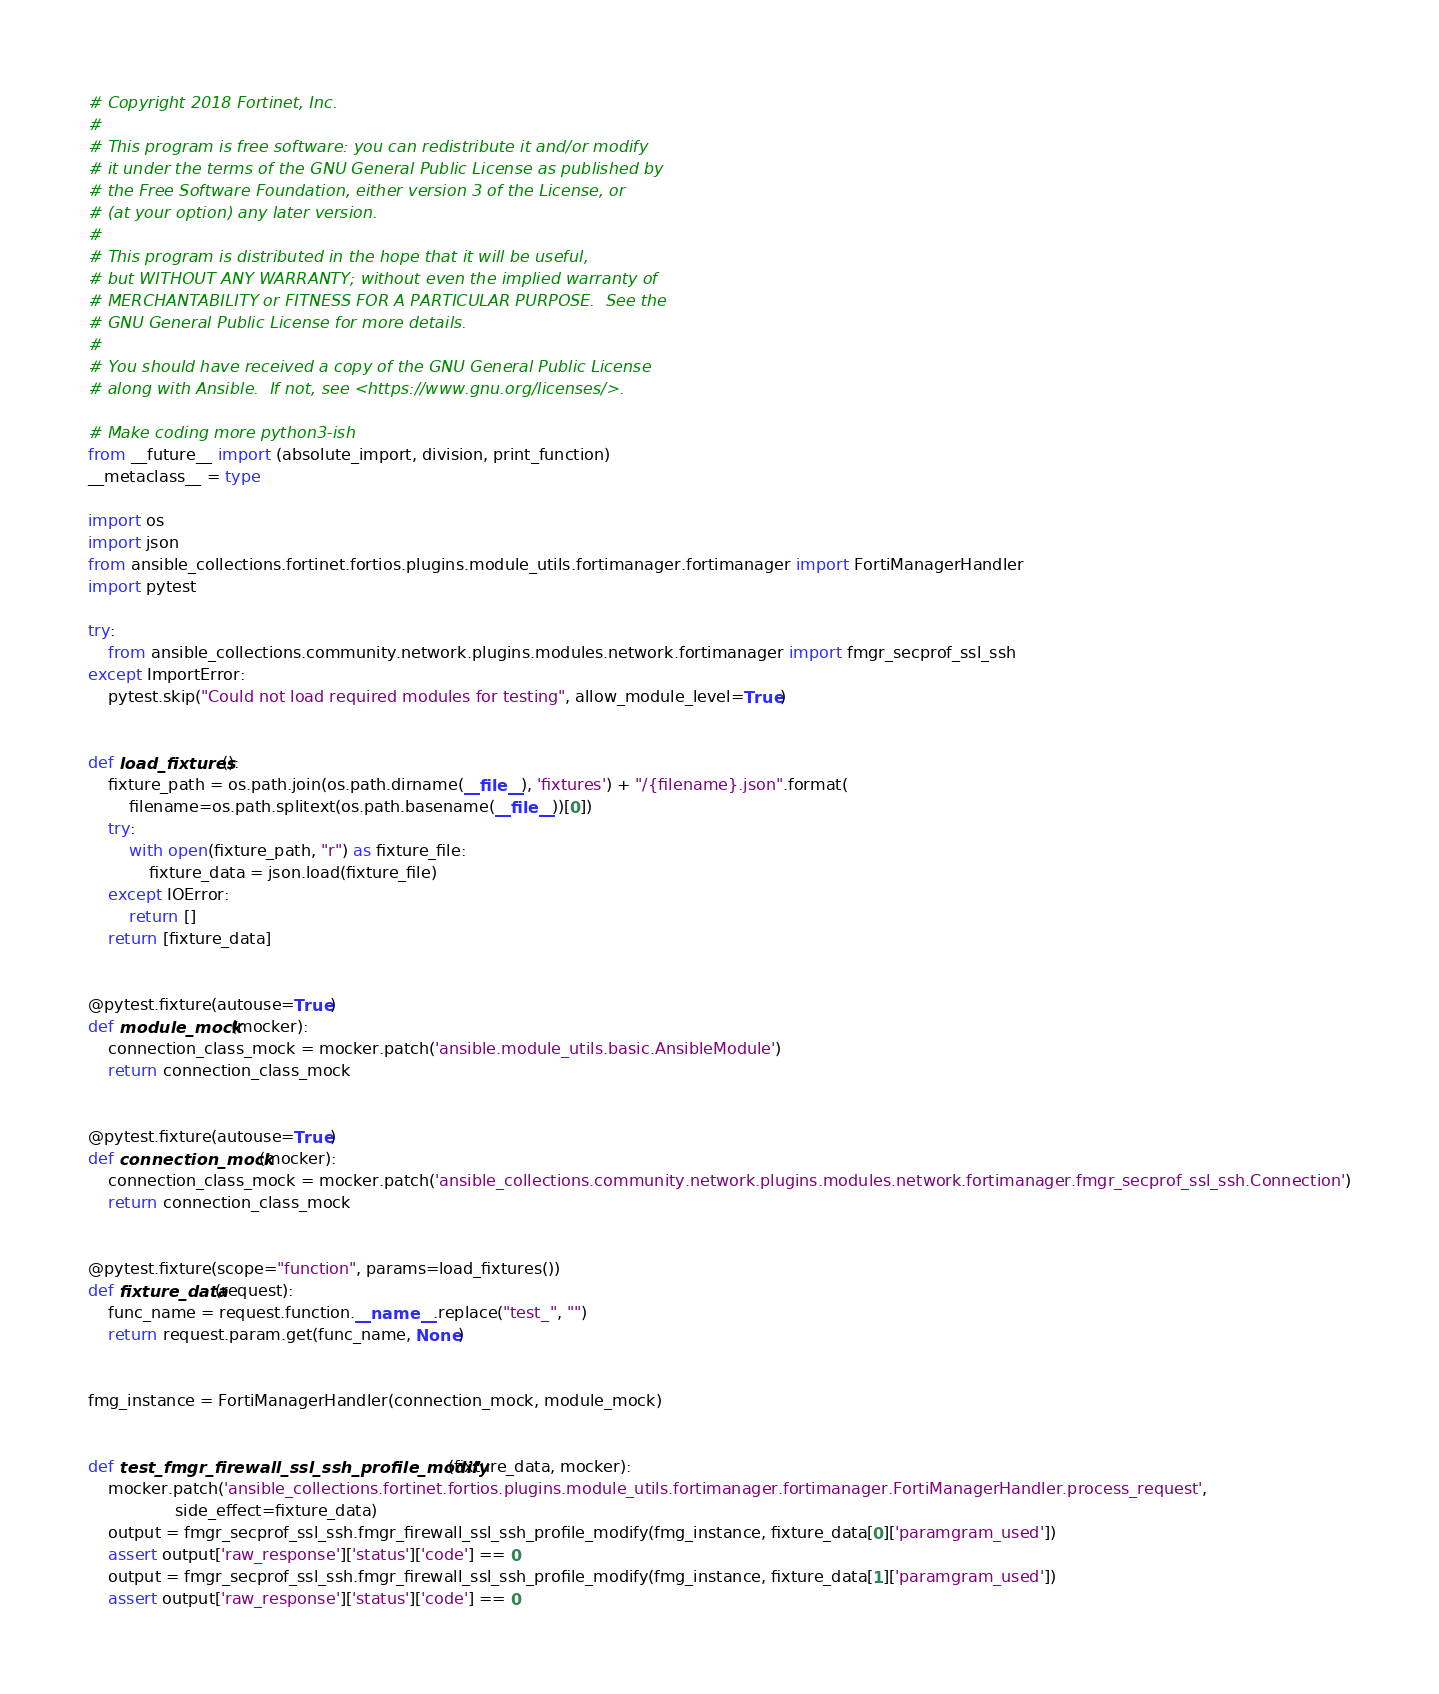<code> <loc_0><loc_0><loc_500><loc_500><_Python_># Copyright 2018 Fortinet, Inc.
#
# This program is free software: you can redistribute it and/or modify
# it under the terms of the GNU General Public License as published by
# the Free Software Foundation, either version 3 of the License, or
# (at your option) any later version.
#
# This program is distributed in the hope that it will be useful,
# but WITHOUT ANY WARRANTY; without even the implied warranty of
# MERCHANTABILITY or FITNESS FOR A PARTICULAR PURPOSE.  See the
# GNU General Public License for more details.
#
# You should have received a copy of the GNU General Public License
# along with Ansible.  If not, see <https://www.gnu.org/licenses/>.

# Make coding more python3-ish
from __future__ import (absolute_import, division, print_function)
__metaclass__ = type

import os
import json
from ansible_collections.fortinet.fortios.plugins.module_utils.fortimanager.fortimanager import FortiManagerHandler
import pytest

try:
    from ansible_collections.community.network.plugins.modules.network.fortimanager import fmgr_secprof_ssl_ssh
except ImportError:
    pytest.skip("Could not load required modules for testing", allow_module_level=True)


def load_fixtures():
    fixture_path = os.path.join(os.path.dirname(__file__), 'fixtures') + "/{filename}.json".format(
        filename=os.path.splitext(os.path.basename(__file__))[0])
    try:
        with open(fixture_path, "r") as fixture_file:
            fixture_data = json.load(fixture_file)
    except IOError:
        return []
    return [fixture_data]


@pytest.fixture(autouse=True)
def module_mock(mocker):
    connection_class_mock = mocker.patch('ansible.module_utils.basic.AnsibleModule')
    return connection_class_mock


@pytest.fixture(autouse=True)
def connection_mock(mocker):
    connection_class_mock = mocker.patch('ansible_collections.community.network.plugins.modules.network.fortimanager.fmgr_secprof_ssl_ssh.Connection')
    return connection_class_mock


@pytest.fixture(scope="function", params=load_fixtures())
def fixture_data(request):
    func_name = request.function.__name__.replace("test_", "")
    return request.param.get(func_name, None)


fmg_instance = FortiManagerHandler(connection_mock, module_mock)


def test_fmgr_firewall_ssl_ssh_profile_modify(fixture_data, mocker):
    mocker.patch('ansible_collections.fortinet.fortios.plugins.module_utils.fortimanager.fortimanager.FortiManagerHandler.process_request',
                 side_effect=fixture_data)
    output = fmgr_secprof_ssl_ssh.fmgr_firewall_ssl_ssh_profile_modify(fmg_instance, fixture_data[0]['paramgram_used'])
    assert output['raw_response']['status']['code'] == 0
    output = fmgr_secprof_ssl_ssh.fmgr_firewall_ssl_ssh_profile_modify(fmg_instance, fixture_data[1]['paramgram_used'])
    assert output['raw_response']['status']['code'] == 0
</code> 